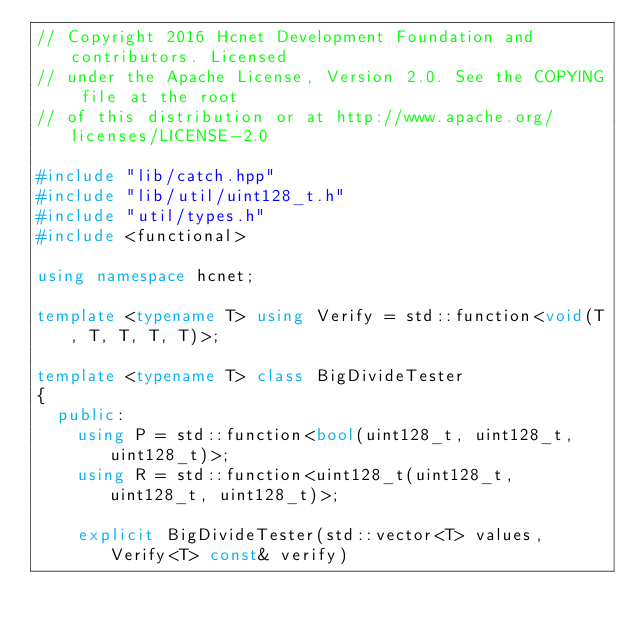<code> <loc_0><loc_0><loc_500><loc_500><_C++_>// Copyright 2016 Hcnet Development Foundation and contributors. Licensed
// under the Apache License, Version 2.0. See the COPYING file at the root
// of this distribution or at http://www.apache.org/licenses/LICENSE-2.0

#include "lib/catch.hpp"
#include "lib/util/uint128_t.h"
#include "util/types.h"
#include <functional>

using namespace hcnet;

template <typename T> using Verify = std::function<void(T, T, T, T, T)>;

template <typename T> class BigDivideTester
{
  public:
    using P = std::function<bool(uint128_t, uint128_t, uint128_t)>;
    using R = std::function<uint128_t(uint128_t, uint128_t, uint128_t)>;

    explicit BigDivideTester(std::vector<T> values, Verify<T> const& verify)</code> 